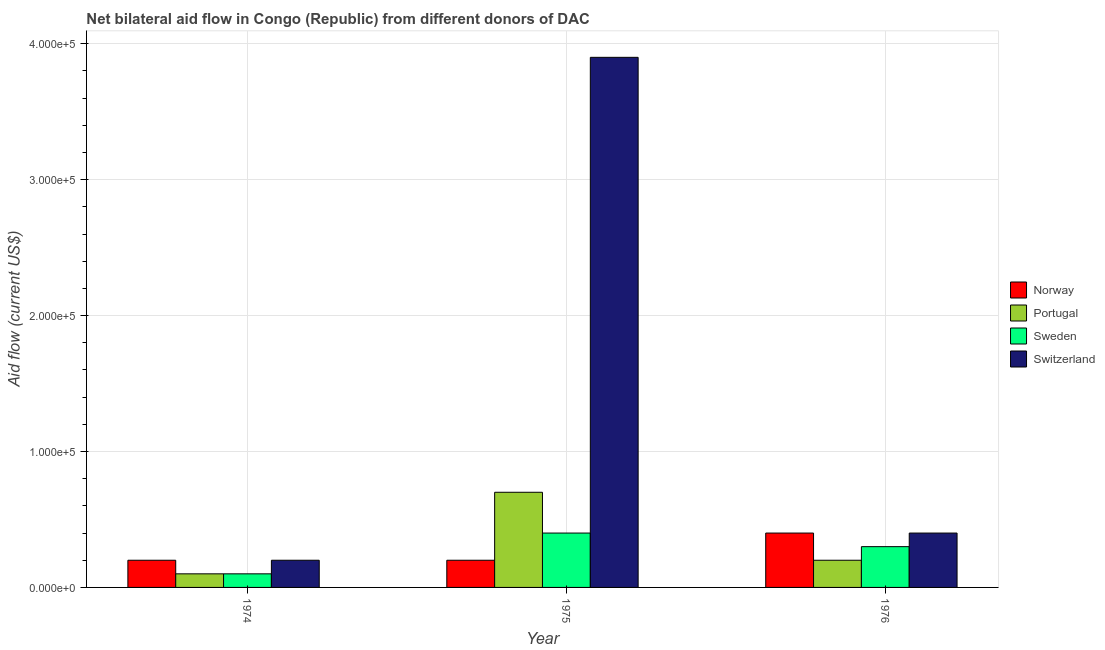Are the number of bars per tick equal to the number of legend labels?
Offer a very short reply. Yes. Are the number of bars on each tick of the X-axis equal?
Offer a terse response. Yes. How many bars are there on the 3rd tick from the left?
Provide a succinct answer. 4. What is the label of the 1st group of bars from the left?
Make the answer very short. 1974. In how many cases, is the number of bars for a given year not equal to the number of legend labels?
Provide a short and direct response. 0. What is the amount of aid given by sweden in 1975?
Make the answer very short. 4.00e+04. Across all years, what is the maximum amount of aid given by norway?
Offer a terse response. 4.00e+04. Across all years, what is the minimum amount of aid given by switzerland?
Make the answer very short. 2.00e+04. In which year was the amount of aid given by sweden maximum?
Keep it short and to the point. 1975. In which year was the amount of aid given by norway minimum?
Your answer should be compact. 1974. What is the total amount of aid given by norway in the graph?
Ensure brevity in your answer.  8.00e+04. What is the difference between the amount of aid given by sweden in 1974 and that in 1975?
Your answer should be compact. -3.00e+04. What is the difference between the amount of aid given by portugal in 1974 and the amount of aid given by switzerland in 1976?
Make the answer very short. -10000. What is the average amount of aid given by sweden per year?
Provide a succinct answer. 2.67e+04. Is the difference between the amount of aid given by norway in 1975 and 1976 greater than the difference between the amount of aid given by portugal in 1975 and 1976?
Offer a very short reply. No. What is the difference between the highest and the lowest amount of aid given by portugal?
Offer a very short reply. 6.00e+04. In how many years, is the amount of aid given by switzerland greater than the average amount of aid given by switzerland taken over all years?
Make the answer very short. 1. Is it the case that in every year, the sum of the amount of aid given by norway and amount of aid given by sweden is greater than the sum of amount of aid given by switzerland and amount of aid given by portugal?
Provide a short and direct response. No. What does the 2nd bar from the left in 1976 represents?
Make the answer very short. Portugal. What does the 2nd bar from the right in 1976 represents?
Make the answer very short. Sweden. Is it the case that in every year, the sum of the amount of aid given by norway and amount of aid given by portugal is greater than the amount of aid given by sweden?
Make the answer very short. Yes. Does the graph contain grids?
Offer a terse response. Yes. What is the title of the graph?
Give a very brief answer. Net bilateral aid flow in Congo (Republic) from different donors of DAC. Does "Agriculture" appear as one of the legend labels in the graph?
Your answer should be very brief. No. What is the label or title of the Y-axis?
Ensure brevity in your answer.  Aid flow (current US$). What is the Aid flow (current US$) in Norway in 1974?
Ensure brevity in your answer.  2.00e+04. What is the Aid flow (current US$) in Portugal in 1974?
Ensure brevity in your answer.  10000. What is the Aid flow (current US$) of Sweden in 1974?
Keep it short and to the point. 10000. What is the Aid flow (current US$) of Norway in 1975?
Your answer should be compact. 2.00e+04. What is the Aid flow (current US$) of Sweden in 1975?
Offer a terse response. 4.00e+04. What is the Aid flow (current US$) in Portugal in 1976?
Provide a succinct answer. 2.00e+04. What is the Aid flow (current US$) in Sweden in 1976?
Ensure brevity in your answer.  3.00e+04. What is the Aid flow (current US$) in Switzerland in 1976?
Provide a succinct answer. 4.00e+04. Across all years, what is the maximum Aid flow (current US$) of Switzerland?
Your answer should be compact. 3.90e+05. Across all years, what is the minimum Aid flow (current US$) in Norway?
Provide a succinct answer. 2.00e+04. Across all years, what is the minimum Aid flow (current US$) in Portugal?
Offer a very short reply. 10000. Across all years, what is the minimum Aid flow (current US$) in Sweden?
Make the answer very short. 10000. Across all years, what is the minimum Aid flow (current US$) in Switzerland?
Your answer should be very brief. 2.00e+04. What is the total Aid flow (current US$) of Portugal in the graph?
Make the answer very short. 1.00e+05. What is the total Aid flow (current US$) in Switzerland in the graph?
Make the answer very short. 4.50e+05. What is the difference between the Aid flow (current US$) of Portugal in 1974 and that in 1975?
Make the answer very short. -6.00e+04. What is the difference between the Aid flow (current US$) in Switzerland in 1974 and that in 1975?
Keep it short and to the point. -3.70e+05. What is the difference between the Aid flow (current US$) in Norway in 1974 and that in 1976?
Your answer should be very brief. -2.00e+04. What is the difference between the Aid flow (current US$) in Sweden in 1974 and that in 1976?
Offer a very short reply. -2.00e+04. What is the difference between the Aid flow (current US$) in Portugal in 1975 and that in 1976?
Provide a succinct answer. 5.00e+04. What is the difference between the Aid flow (current US$) of Switzerland in 1975 and that in 1976?
Provide a succinct answer. 3.50e+05. What is the difference between the Aid flow (current US$) in Norway in 1974 and the Aid flow (current US$) in Portugal in 1975?
Your answer should be very brief. -5.00e+04. What is the difference between the Aid flow (current US$) of Norway in 1974 and the Aid flow (current US$) of Sweden in 1975?
Your answer should be very brief. -2.00e+04. What is the difference between the Aid flow (current US$) in Norway in 1974 and the Aid flow (current US$) in Switzerland in 1975?
Offer a terse response. -3.70e+05. What is the difference between the Aid flow (current US$) of Portugal in 1974 and the Aid flow (current US$) of Switzerland in 1975?
Make the answer very short. -3.80e+05. What is the difference between the Aid flow (current US$) in Sweden in 1974 and the Aid flow (current US$) in Switzerland in 1975?
Offer a terse response. -3.80e+05. What is the difference between the Aid flow (current US$) in Norway in 1974 and the Aid flow (current US$) in Sweden in 1976?
Your answer should be compact. -10000. What is the difference between the Aid flow (current US$) of Norway in 1974 and the Aid flow (current US$) of Switzerland in 1976?
Make the answer very short. -2.00e+04. What is the difference between the Aid flow (current US$) of Portugal in 1974 and the Aid flow (current US$) of Sweden in 1976?
Provide a short and direct response. -2.00e+04. What is the difference between the Aid flow (current US$) of Norway in 1975 and the Aid flow (current US$) of Portugal in 1976?
Ensure brevity in your answer.  0. What is the difference between the Aid flow (current US$) of Norway in 1975 and the Aid flow (current US$) of Switzerland in 1976?
Your answer should be compact. -2.00e+04. What is the difference between the Aid flow (current US$) of Portugal in 1975 and the Aid flow (current US$) of Switzerland in 1976?
Provide a succinct answer. 3.00e+04. What is the difference between the Aid flow (current US$) in Sweden in 1975 and the Aid flow (current US$) in Switzerland in 1976?
Offer a very short reply. 0. What is the average Aid flow (current US$) of Norway per year?
Provide a succinct answer. 2.67e+04. What is the average Aid flow (current US$) in Portugal per year?
Your answer should be very brief. 3.33e+04. What is the average Aid flow (current US$) of Sweden per year?
Offer a terse response. 2.67e+04. What is the average Aid flow (current US$) of Switzerland per year?
Your response must be concise. 1.50e+05. In the year 1974, what is the difference between the Aid flow (current US$) of Norway and Aid flow (current US$) of Portugal?
Your response must be concise. 10000. In the year 1974, what is the difference between the Aid flow (current US$) of Portugal and Aid flow (current US$) of Sweden?
Your answer should be very brief. 0. In the year 1974, what is the difference between the Aid flow (current US$) in Portugal and Aid flow (current US$) in Switzerland?
Offer a terse response. -10000. In the year 1975, what is the difference between the Aid flow (current US$) of Norway and Aid flow (current US$) of Sweden?
Provide a succinct answer. -2.00e+04. In the year 1975, what is the difference between the Aid flow (current US$) in Norway and Aid flow (current US$) in Switzerland?
Give a very brief answer. -3.70e+05. In the year 1975, what is the difference between the Aid flow (current US$) of Portugal and Aid flow (current US$) of Switzerland?
Make the answer very short. -3.20e+05. In the year 1975, what is the difference between the Aid flow (current US$) in Sweden and Aid flow (current US$) in Switzerland?
Offer a very short reply. -3.50e+05. In the year 1976, what is the difference between the Aid flow (current US$) of Norway and Aid flow (current US$) of Portugal?
Provide a short and direct response. 2.00e+04. In the year 1976, what is the difference between the Aid flow (current US$) of Portugal and Aid flow (current US$) of Switzerland?
Provide a short and direct response. -2.00e+04. What is the ratio of the Aid flow (current US$) in Portugal in 1974 to that in 1975?
Provide a succinct answer. 0.14. What is the ratio of the Aid flow (current US$) of Sweden in 1974 to that in 1975?
Your answer should be compact. 0.25. What is the ratio of the Aid flow (current US$) of Switzerland in 1974 to that in 1975?
Offer a terse response. 0.05. What is the ratio of the Aid flow (current US$) in Norway in 1974 to that in 1976?
Keep it short and to the point. 0.5. What is the ratio of the Aid flow (current US$) of Portugal in 1974 to that in 1976?
Ensure brevity in your answer.  0.5. What is the ratio of the Aid flow (current US$) of Switzerland in 1974 to that in 1976?
Give a very brief answer. 0.5. What is the ratio of the Aid flow (current US$) in Norway in 1975 to that in 1976?
Ensure brevity in your answer.  0.5. What is the ratio of the Aid flow (current US$) in Sweden in 1975 to that in 1976?
Give a very brief answer. 1.33. What is the ratio of the Aid flow (current US$) of Switzerland in 1975 to that in 1976?
Make the answer very short. 9.75. What is the difference between the highest and the second highest Aid flow (current US$) in Sweden?
Keep it short and to the point. 10000. What is the difference between the highest and the second highest Aid flow (current US$) of Switzerland?
Offer a terse response. 3.50e+05. What is the difference between the highest and the lowest Aid flow (current US$) of Portugal?
Offer a terse response. 6.00e+04. 